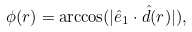<formula> <loc_0><loc_0><loc_500><loc_500>\phi ( r ) = \arccos ( | \hat { e } _ { 1 } \cdot { \hat { d } } ( r ) | ) ,</formula> 